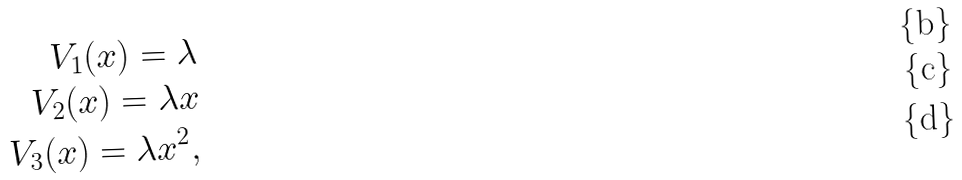Convert formula to latex. <formula><loc_0><loc_0><loc_500><loc_500>V _ { 1 } ( x ) = \lambda \\ V _ { 2 } ( x ) = \lambda x \\ V _ { 3 } ( x ) = \lambda x ^ { 2 } ,</formula> 